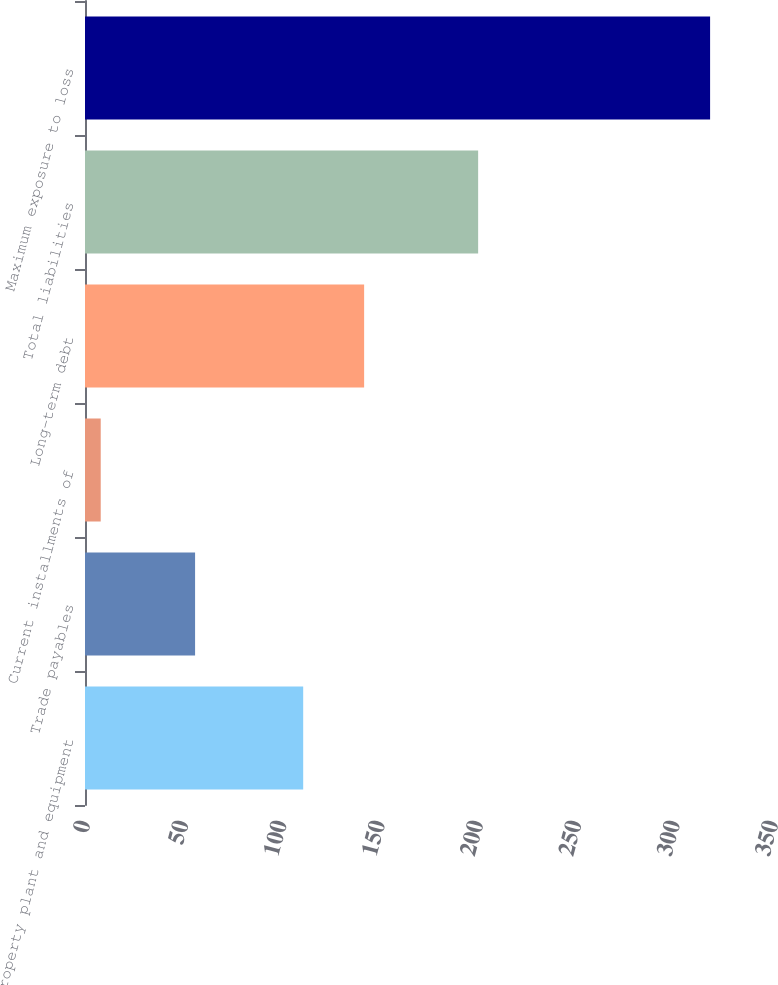Convert chart to OTSL. <chart><loc_0><loc_0><loc_500><loc_500><bar_chart><fcel>Property plant and equipment<fcel>Trade payables<fcel>Current installments of<fcel>Long-term debt<fcel>Total liabilities<fcel>Maximum exposure to loss<nl><fcel>111<fcel>56<fcel>8<fcel>142<fcel>200<fcel>318<nl></chart> 